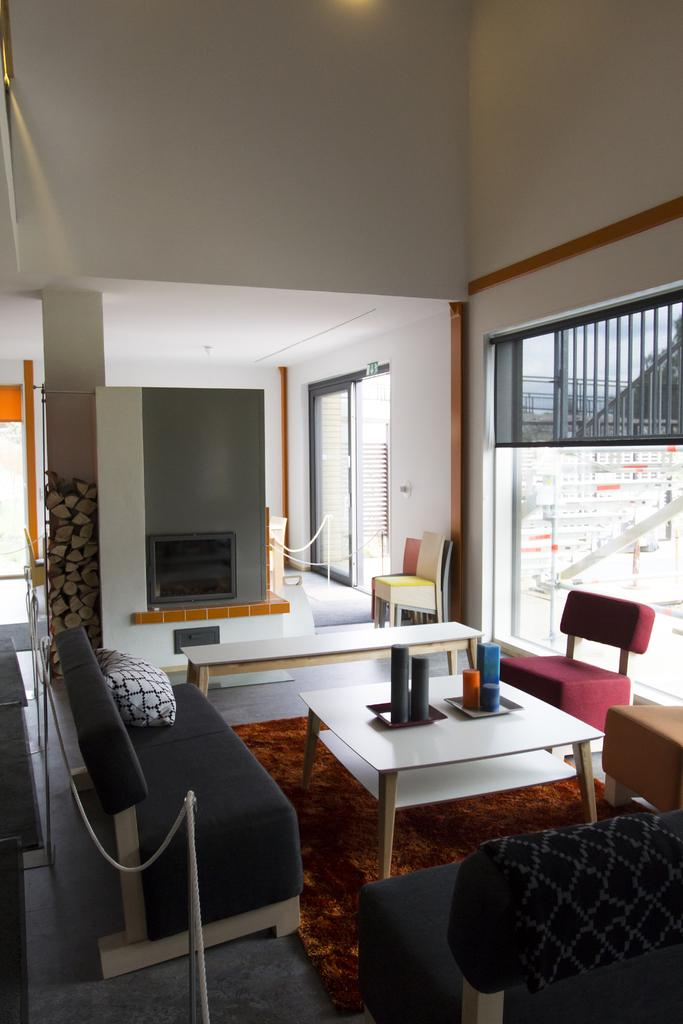What type of space is depicted in the image? The image shows an inside view of a room. What type of furniture can be seen in the room? There are sofas and chairs in the room. What other objects are present in the room? There is a table and a glass in the room. What surrounds the room? There are walls in the room. What type of flag is hanging on the wall in the room? There is no flag present in the image; only sofas, chairs, a table, a glass, and walls are visible. Can you see a cord attached to the glass in the image? There is no cord visible in the image; only a glass is present. 